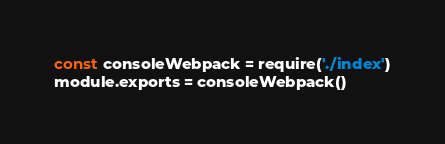Convert code to text. <code><loc_0><loc_0><loc_500><loc_500><_JavaScript_>const consoleWebpack = require('./index')
module.exports = consoleWebpack()</code> 